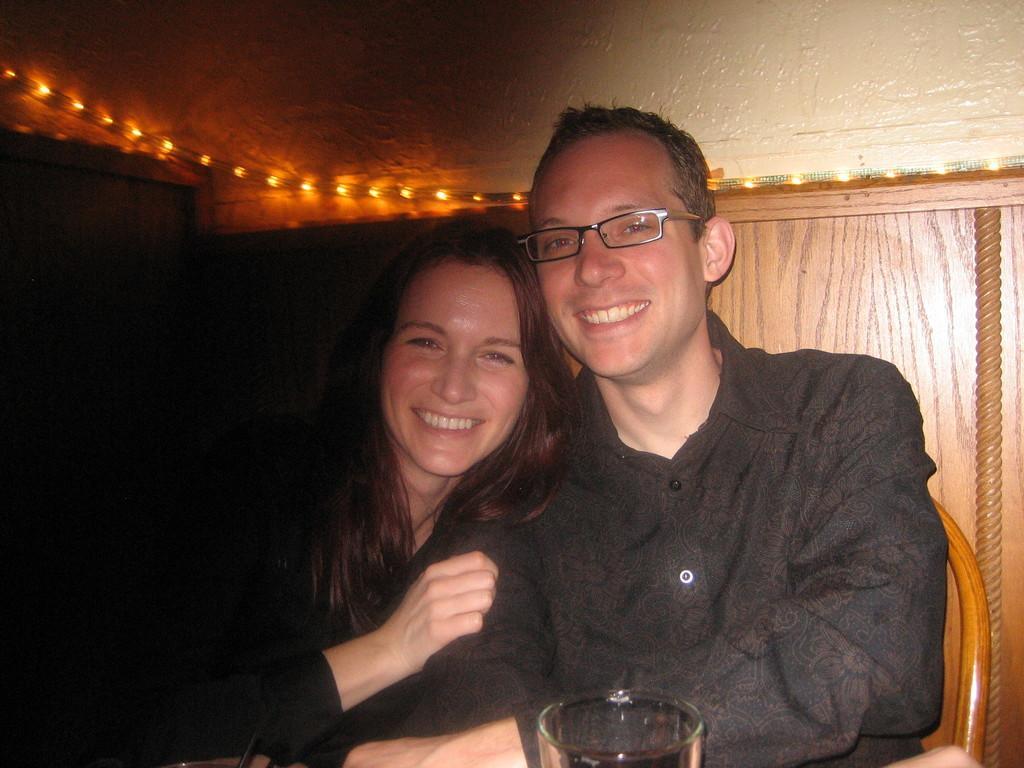In one or two sentences, can you explain what this image depicts? In this image I can see a person wearing black colored shirt and a woman wearing black color dress are sitting on chairs and I can see a glass in front of them. In the background I can see the brown colored surface and few lights which are orange in color. 